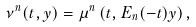Convert formula to latex. <formula><loc_0><loc_0><loc_500><loc_500>\nu ^ { n } ( t , y ) = \mu ^ { n } \left ( t , E _ { n } ( - t ) y \right ) ,</formula> 